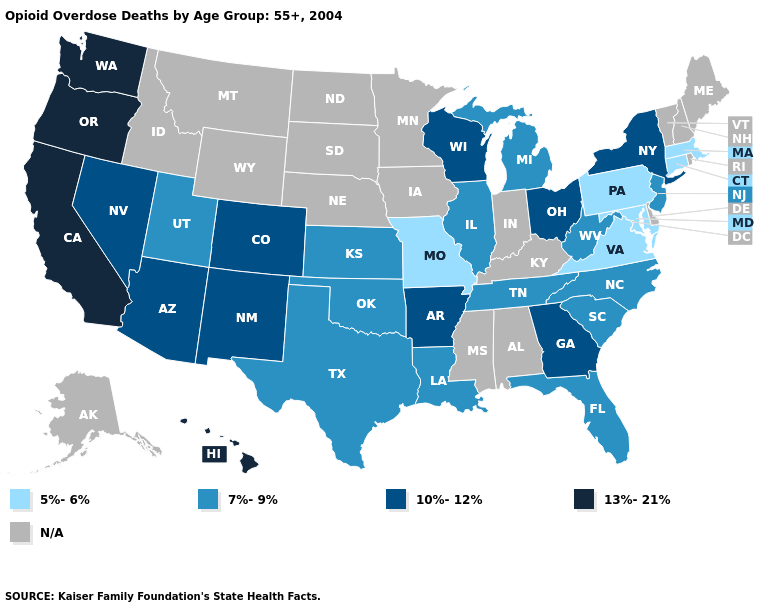Name the states that have a value in the range 13%-21%?
Be succinct. California, Hawaii, Oregon, Washington. Among the states that border Colorado , which have the lowest value?
Give a very brief answer. Kansas, Oklahoma, Utah. Among the states that border Pennsylvania , does Ohio have the highest value?
Write a very short answer. Yes. Name the states that have a value in the range 7%-9%?
Short answer required. Florida, Illinois, Kansas, Louisiana, Michigan, New Jersey, North Carolina, Oklahoma, South Carolina, Tennessee, Texas, Utah, West Virginia. Among the states that border California , which have the lowest value?
Concise answer only. Arizona, Nevada. What is the lowest value in states that border Indiana?
Write a very short answer. 7%-9%. Does Georgia have the lowest value in the South?
Write a very short answer. No. What is the highest value in the Northeast ?
Concise answer only. 10%-12%. Which states have the lowest value in the MidWest?
Be succinct. Missouri. Does Arkansas have the highest value in the South?
Give a very brief answer. Yes. Which states have the highest value in the USA?
Write a very short answer. California, Hawaii, Oregon, Washington. Does California have the highest value in the USA?
Quick response, please. Yes. Does Virginia have the highest value in the South?
Give a very brief answer. No. Name the states that have a value in the range 5%-6%?
Concise answer only. Connecticut, Maryland, Massachusetts, Missouri, Pennsylvania, Virginia. 